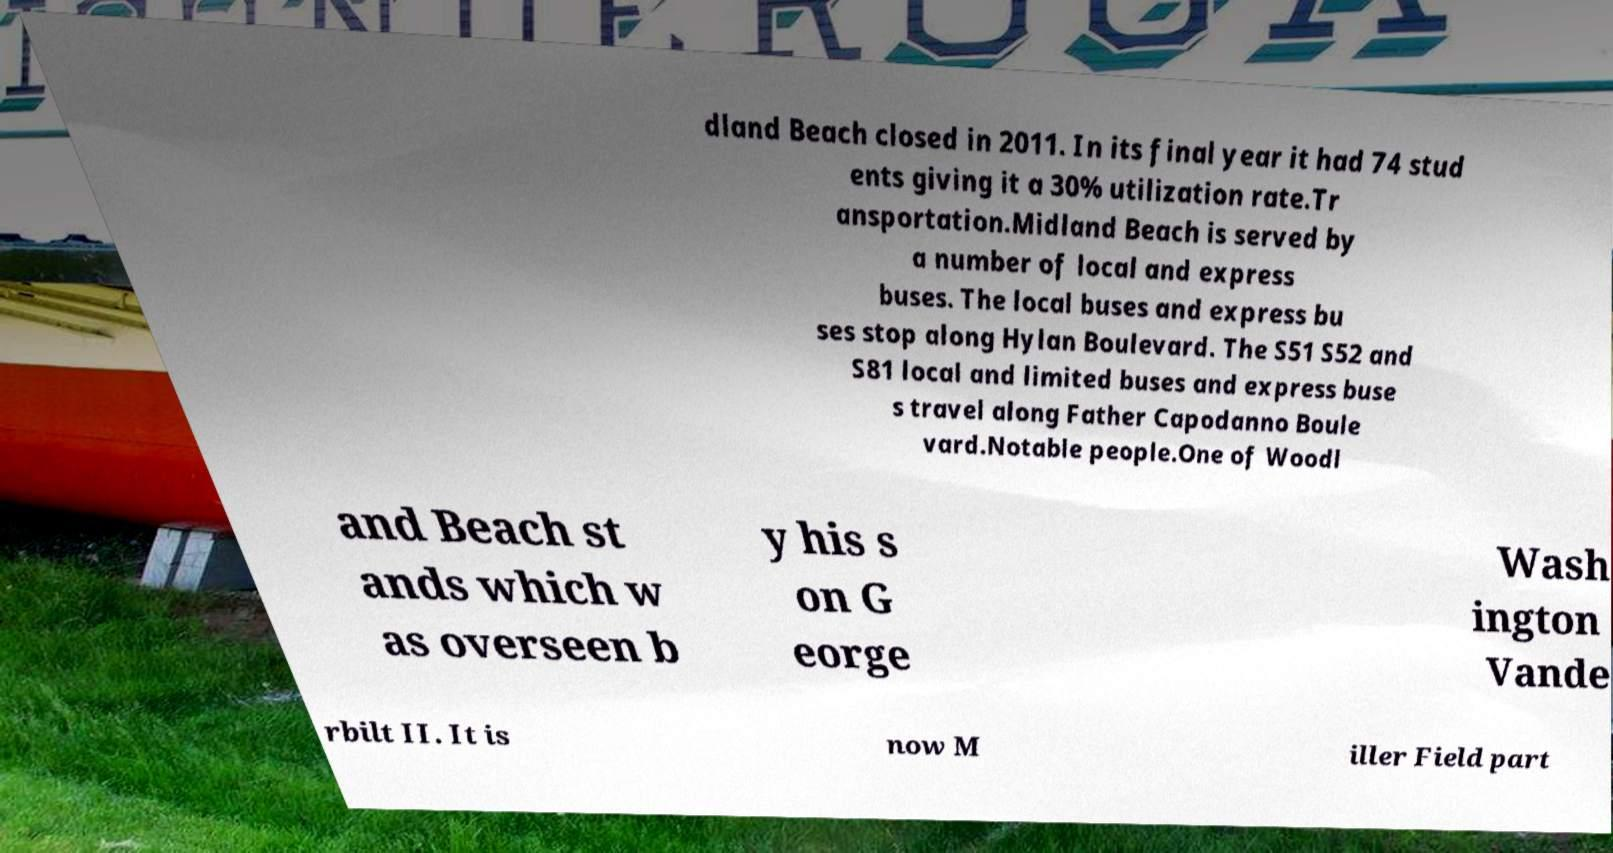What messages or text are displayed in this image? I need them in a readable, typed format. dland Beach closed in 2011. In its final year it had 74 stud ents giving it a 30% utilization rate.Tr ansportation.Midland Beach is served by a number of local and express buses. The local buses and express bu ses stop along Hylan Boulevard. The S51 S52 and S81 local and limited buses and express buse s travel along Father Capodanno Boule vard.Notable people.One of Woodl and Beach st ands which w as overseen b y his s on G eorge Wash ington Vande rbilt II. It is now M iller Field part 